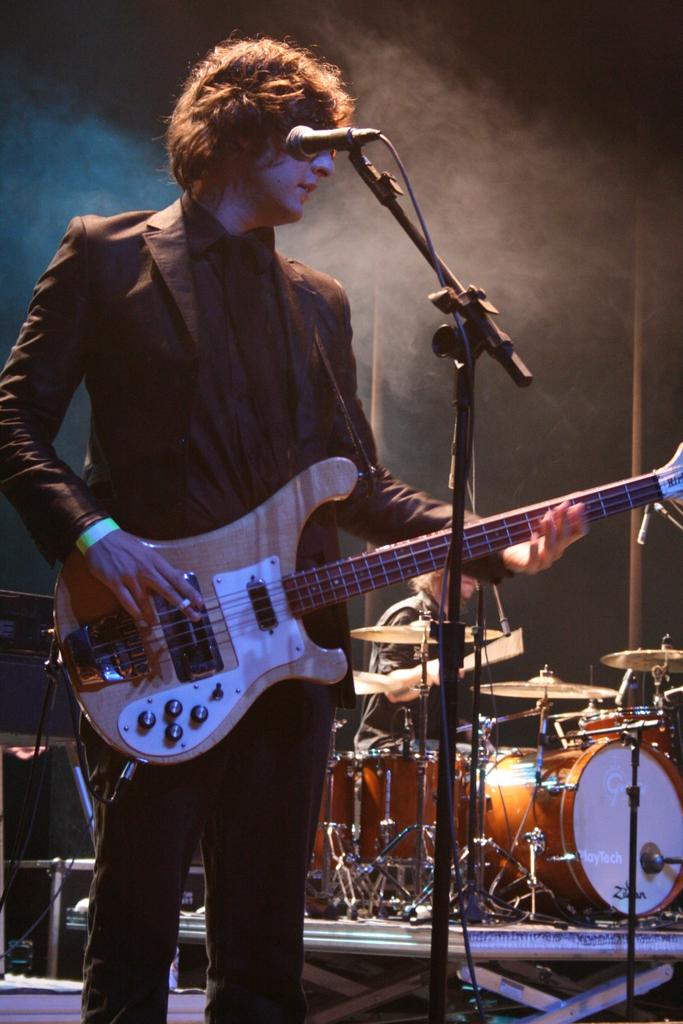What is the man in the image holding? The man is holding a guitar. What is the man wearing in the image? The man is wearing a black suit. What object is present in the image that is typically used for amplifying sound? There is a microphone (mike) in the image. What can be seen in the background of the image that suggests a musical setting? There are musical instruments in the background of the image. What type of vegetable is the man eating in the image? There is no vegetable present in the image; the man is holding a guitar and wearing a black suit. 